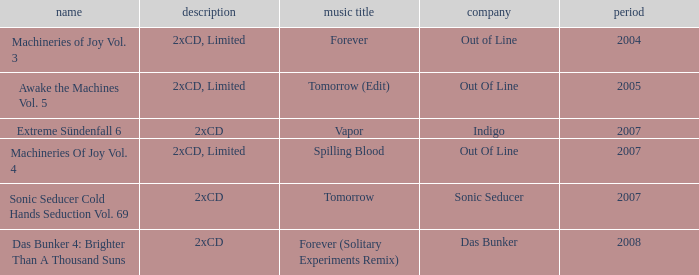Would you mind parsing the complete table? {'header': ['name', 'description', 'music title', 'company', 'period'], 'rows': [['Machineries of Joy Vol. 3', '2xCD, Limited', 'Forever', 'Out of Line', '2004'], ['Awake the Machines Vol. 5', '2xCD, Limited', 'Tomorrow (Edit)', 'Out Of Line', '2005'], ['Extreme Sündenfall 6', '2xCD', 'Vapor', 'Indigo', '2007'], ['Machineries Of Joy Vol. 4', '2xCD, Limited', 'Spilling Blood', 'Out Of Line', '2007'], ['Sonic Seducer Cold Hands Seduction Vol. 69', '2xCD', 'Tomorrow', 'Sonic Seducer', '2007'], ['Das Bunker 4: Brighter Than A Thousand Suns', '2xCD', 'Forever (Solitary Experiments Remix)', 'Das Bunker', '2008']]} Which label has a year older than 2004 and a 2xcd detail as well as the sonic seducer cold hands seduction vol. 69 title? Sonic Seducer. 